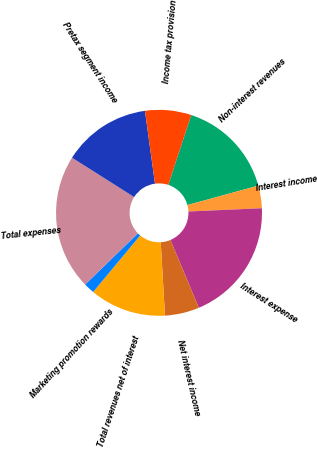Convert chart. <chart><loc_0><loc_0><loc_500><loc_500><pie_chart><fcel>Non-interest revenues<fcel>Interest income<fcel>Interest expense<fcel>Net interest income<fcel>Total revenues net of interest<fcel>Marketing promotion rewards<fcel>Total expenses<fcel>Pretax segment income<fcel>Income tax provision<nl><fcel>15.68%<fcel>3.54%<fcel>19.39%<fcel>5.4%<fcel>11.97%<fcel>1.69%<fcel>21.25%<fcel>13.83%<fcel>7.25%<nl></chart> 